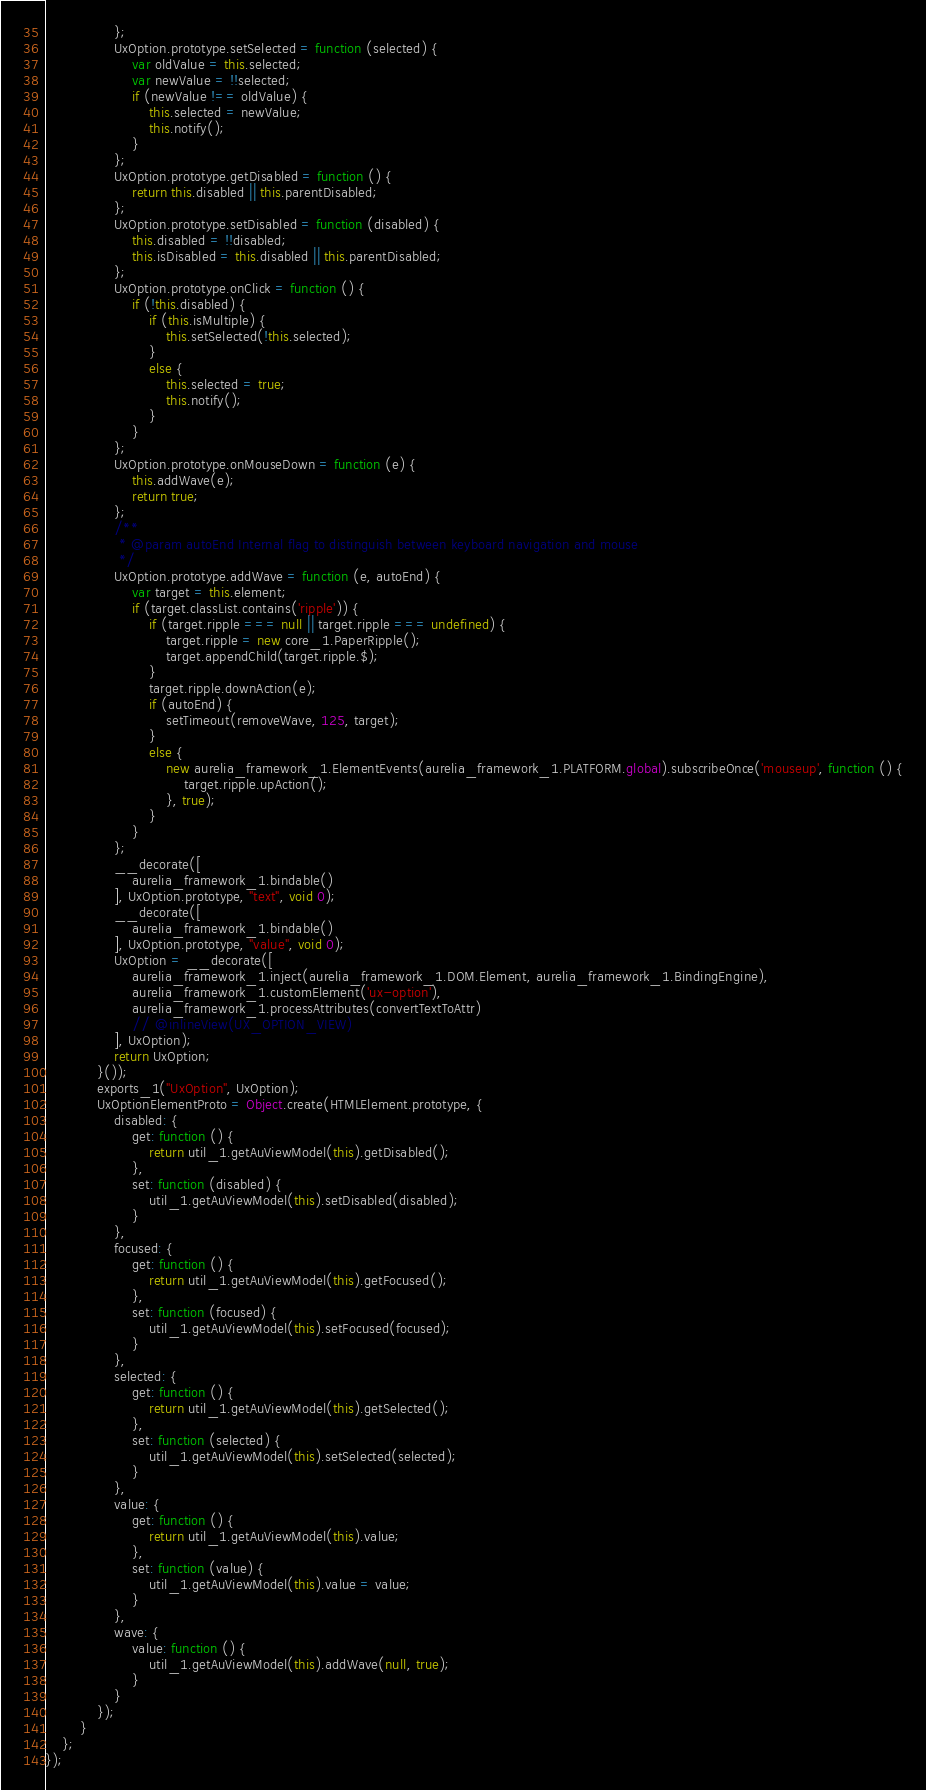Convert code to text. <code><loc_0><loc_0><loc_500><loc_500><_JavaScript_>                };
                UxOption.prototype.setSelected = function (selected) {
                    var oldValue = this.selected;
                    var newValue = !!selected;
                    if (newValue !== oldValue) {
                        this.selected = newValue;
                        this.notify();
                    }
                };
                UxOption.prototype.getDisabled = function () {
                    return this.disabled || this.parentDisabled;
                };
                UxOption.prototype.setDisabled = function (disabled) {
                    this.disabled = !!disabled;
                    this.isDisabled = this.disabled || this.parentDisabled;
                };
                UxOption.prototype.onClick = function () {
                    if (!this.disabled) {
                        if (this.isMultiple) {
                            this.setSelected(!this.selected);
                        }
                        else {
                            this.selected = true;
                            this.notify();
                        }
                    }
                };
                UxOption.prototype.onMouseDown = function (e) {
                    this.addWave(e);
                    return true;
                };
                /**
                 * @param autoEnd Internal flag to distinguish between keyboard navigation and mouse
                 */
                UxOption.prototype.addWave = function (e, autoEnd) {
                    var target = this.element;
                    if (target.classList.contains('ripple')) {
                        if (target.ripple === null || target.ripple === undefined) {
                            target.ripple = new core_1.PaperRipple();
                            target.appendChild(target.ripple.$);
                        }
                        target.ripple.downAction(e);
                        if (autoEnd) {
                            setTimeout(removeWave, 125, target);
                        }
                        else {
                            new aurelia_framework_1.ElementEvents(aurelia_framework_1.PLATFORM.global).subscribeOnce('mouseup', function () {
                                target.ripple.upAction();
                            }, true);
                        }
                    }
                };
                __decorate([
                    aurelia_framework_1.bindable()
                ], UxOption.prototype, "text", void 0);
                __decorate([
                    aurelia_framework_1.bindable()
                ], UxOption.prototype, "value", void 0);
                UxOption = __decorate([
                    aurelia_framework_1.inject(aurelia_framework_1.DOM.Element, aurelia_framework_1.BindingEngine),
                    aurelia_framework_1.customElement('ux-option'),
                    aurelia_framework_1.processAttributes(convertTextToAttr)
                    // @inlineView(UX_OPTION_VIEW)
                ], UxOption);
                return UxOption;
            }());
            exports_1("UxOption", UxOption);
            UxOptionElementProto = Object.create(HTMLElement.prototype, {
                disabled: {
                    get: function () {
                        return util_1.getAuViewModel(this).getDisabled();
                    },
                    set: function (disabled) {
                        util_1.getAuViewModel(this).setDisabled(disabled);
                    }
                },
                focused: {
                    get: function () {
                        return util_1.getAuViewModel(this).getFocused();
                    },
                    set: function (focused) {
                        util_1.getAuViewModel(this).setFocused(focused);
                    }
                },
                selected: {
                    get: function () {
                        return util_1.getAuViewModel(this).getSelected();
                    },
                    set: function (selected) {
                        util_1.getAuViewModel(this).setSelected(selected);
                    }
                },
                value: {
                    get: function () {
                        return util_1.getAuViewModel(this).value;
                    },
                    set: function (value) {
                        util_1.getAuViewModel(this).value = value;
                    }
                },
                wave: {
                    value: function () {
                        util_1.getAuViewModel(this).addWave(null, true);
                    }
                }
            });
        }
    };
});
</code> 